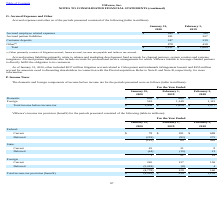From Vmware's financial document, Which years does the table provide information for VMware’s income tax provision (benefit)? The document contains multiple relevant values: 2020, 2019, 2018. From the document: "2020 2019 2020 2019 2020 2019 2018..." Also, What was the current federal income tax provision in 2019? According to the financial document, 181 (in millions). The relevant text states: "Accrued partner liabilities 181 207..." Also, What was the current state income tax provision in 2020? According to the financial document, 45 (in millions). The relevant text states: "Current 45 31 8..." Also, can you calculate: What was the change in the current federal income tax provision between 2018 and 2019? Based on the calculation: 181-688, the result is -507 (in millions). This is based on the information: "Current $ 78 $ 181 $ 688 Accrued partner liabilities 181 207..." The key data points involved are: 181, 688. Also, How many years did current foreign income tax provision exceed $200 million? Based on the analysis, there are 1 instances. The counting process: 2020. Also, can you calculate: What was the percentage change in the Total income tax provision between 2018 and 2019? To answer this question, I need to perform calculations using the financial data. The calculation is: (239-1,152)/1,152, which equals -79.25 (percentage). This is based on the information: "income tax provision (benefit) $ (4,918) $ 239 $ 1,152 Customer deposits 247 239..." The key data points involved are: 1,152, 239. 